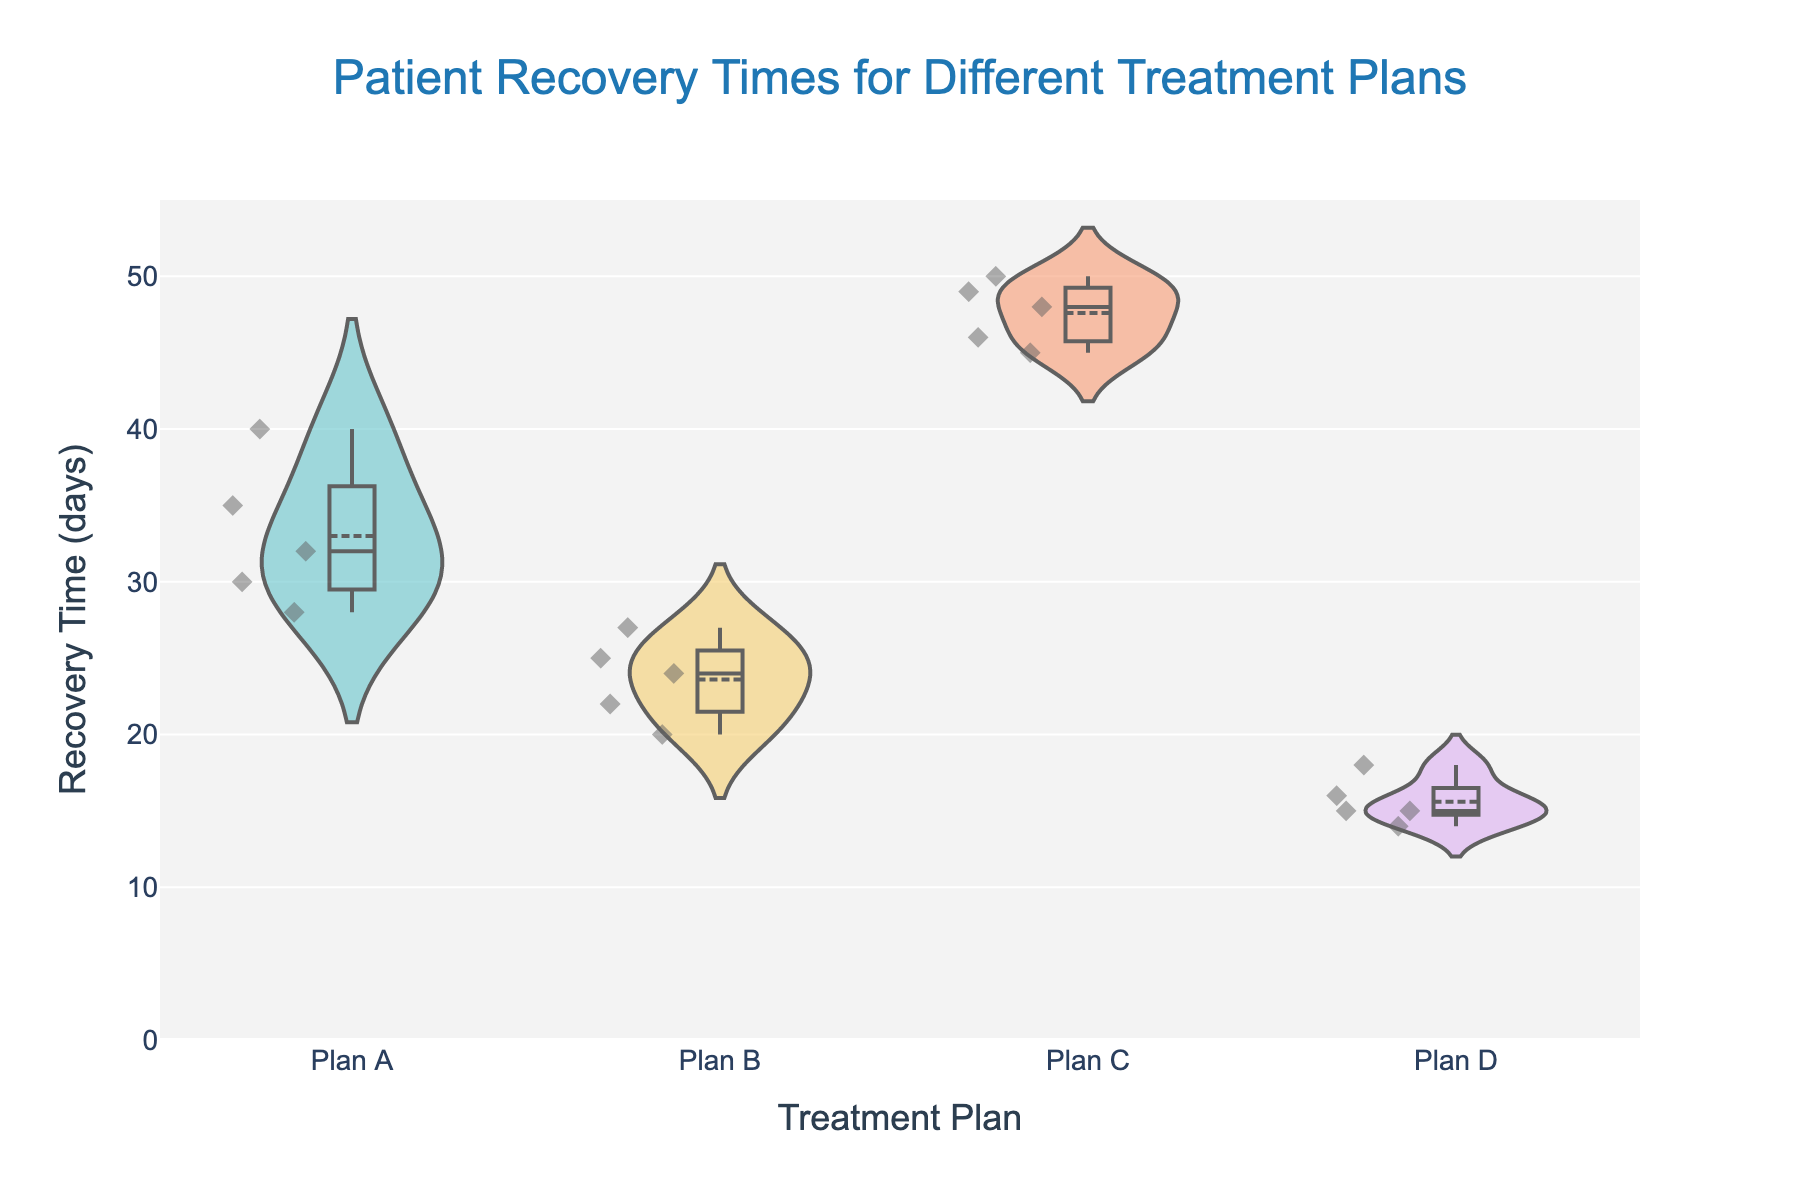What's the title of the figure? The title is clearly located at the top of the figure. It reads "Patient Recovery Times for Different Treatment Plans".
Answer: Patient Recovery Times for Different Treatment Plans What is shown on the y-axis? The label on the y-axis indicates that it reflects "Recovery Time (days)".
Answer: Recovery Time (days) Which treatment plan has the longest average recovery time? By looking at the mean line (horizontal line) in the violin plots, Plan C has the highest mean recovery time when compared with the others.
Answer: Plan C How many data points are there for Plan B? The jittered points represent individual data points. By counting these points for Plan B, there are 5 data points.
Answer: 5 Which treatment plan shows the most variability in recovery times? The spread of the violin plot represents variability. Plan C has the widest spread, indicating the most variability.
Answer: Plan C What is the shortest recovery time observed, and which treatment plan does it belong to? The lowest point in all the violin plots indicates the shortest recovery time, which is 14 days under Plan D.
Answer: 14 days, Plan D Compare the median recovery times of Plan A and Plan D. Which one is higher? The median is represented by the white dot in the violin plot. The median of Plan A is higher than the median of Plan D.
Answer: Plan A What is the range of recovery times for Plan C? The range is the difference between the maximum and minimum values. For Plan C, the maximum recovery time is 50 days, and the minimum is 45 days. Therefore, the range is 50 - 45 = 5 days.
Answer: 5 days Are there any treatment plans that have identical minimum and maximum recovery times? By checking the violin plots, all treatment plans show a range of recovery times, hence none have identical minimum and maximum recovery times.
Answer: No Which treatment plan has the most tightly clustered recovery times near the mean? The clustering of points near the mean line indicates variation. Plan D has points that are more tightly clustered around the mean than the other plans.
Answer: Plan D 